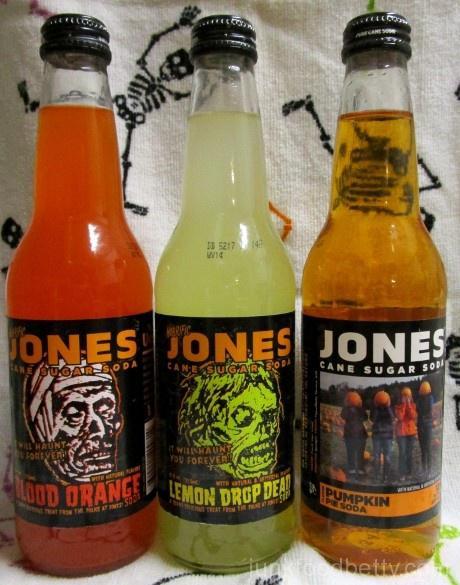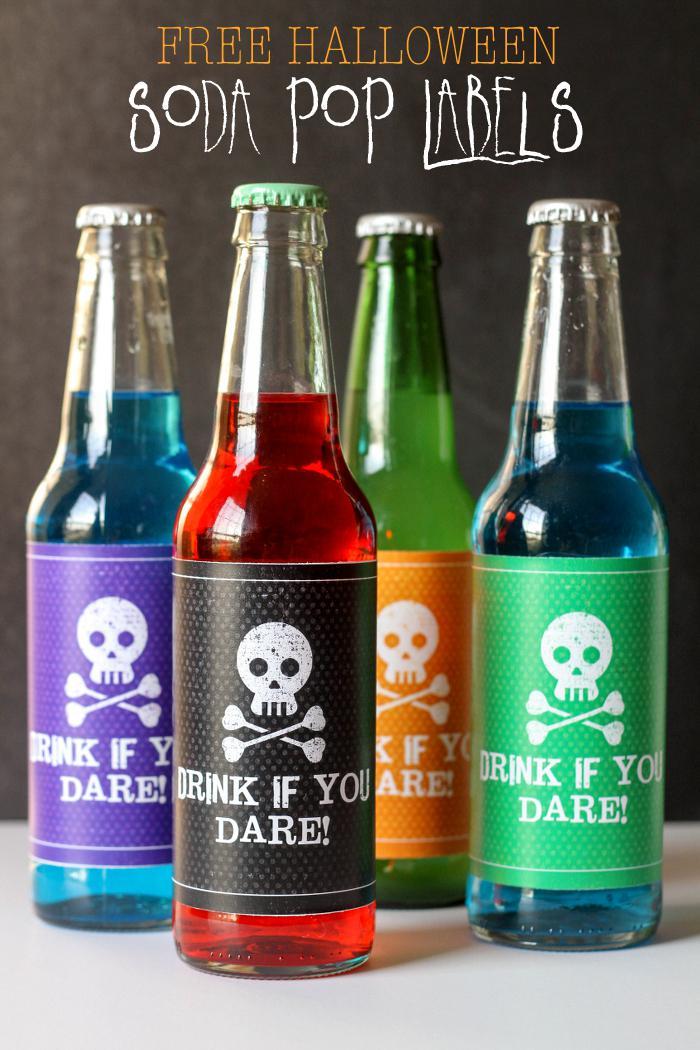The first image is the image on the left, the second image is the image on the right. Given the left and right images, does the statement "There are exactly seven bottles in total." hold true? Answer yes or no. Yes. The first image is the image on the left, the second image is the image on the right. Examine the images to the left and right. Is the description "There are seven bottles in total." accurate? Answer yes or no. Yes. 